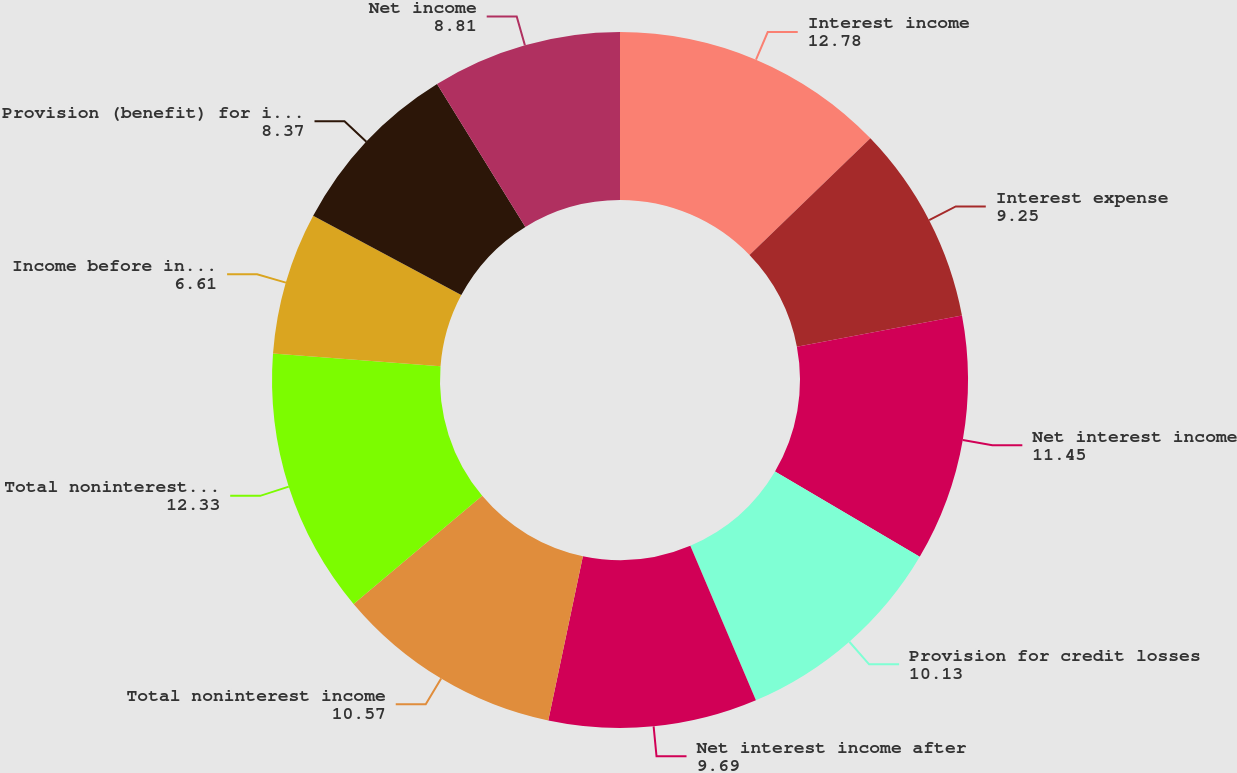Convert chart to OTSL. <chart><loc_0><loc_0><loc_500><loc_500><pie_chart><fcel>Interest income<fcel>Interest expense<fcel>Net interest income<fcel>Provision for credit losses<fcel>Net interest income after<fcel>Total noninterest income<fcel>Total noninterest expense<fcel>Income before income taxes<fcel>Provision (benefit) for income<fcel>Net income<nl><fcel>12.78%<fcel>9.25%<fcel>11.45%<fcel>10.13%<fcel>9.69%<fcel>10.57%<fcel>12.33%<fcel>6.61%<fcel>8.37%<fcel>8.81%<nl></chart> 